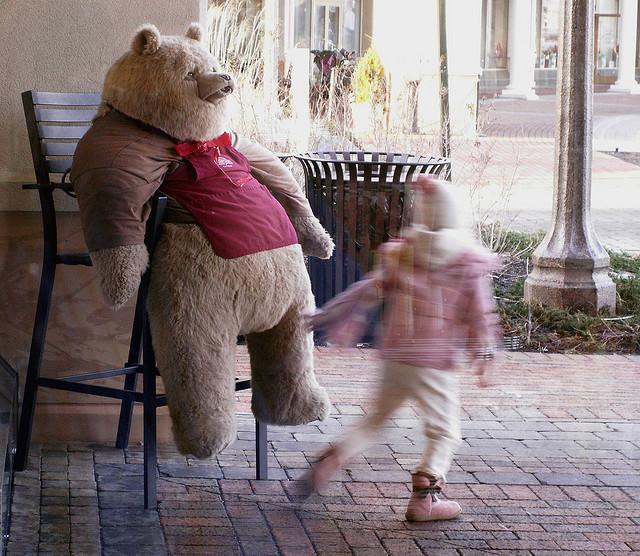Is the bear sitting in a chair?
Concise answer only. Yes. How many overstuffed, large bears?
Keep it brief. 1. Is the garbage can overflowing?
Concise answer only. No. 